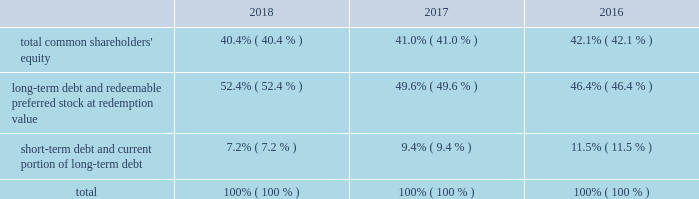Allows us to repurchase shares at times when we may otherwise be prevented from doing so under insider trading laws or because of self-imposed trading blackout periods .
Subject to applicable regulations , we may elect to amend or cancel this repurchase program or the share repurchase parameters at our discretion .
As of december 31 , 2018 , we have repurchased an aggregate of 4510000 shares of common stock under this program .
Credit facilities and short-term debt we have an unsecured revolving credit facility of $ 2.25 billion that expires in june 2023 .
In march 2018 , awcc and its lenders amended and restated the credit agreement with respect to awcc 2019s revolving credit facility to increase the maximum commitments under the facility from $ 1.75 billion to $ 2.25 billion , and to extend the expiration date of the facility from june 2020 to march 2023 .
All other terms , conditions and covenants with respect to the existing facility remained unchanged .
Subject to satisfying certain conditions , the credit agreement also permits awcc to increase the maximum commitment under the facility by up to an aggregate of $ 500 million , and to request extensions of its expiration date for up to two , one-year periods .
Interest rates on advances under the facility are based on a credit spread to the libor rate or base rate in accordance with moody investors service 2019s and standard & poor 2019s financial services 2019 then applicable credit rating on awcc 2019s senior unsecured , non-credit enhanced debt .
The facility is used principally to support awcc 2019s commercial paper program and to provide up to $ 150 million in letters of credit .
Indebtedness under the facility is considered 201cdebt 201d for purposes of a support agreement between the company and awcc , which serves as a functional equivalent of a guarantee by the company of awcc 2019s payment obligations under the credit facility .
Awcc also has an outstanding commercial paper program that is backed by the revolving credit facility , the maximum aggregate outstanding amount of which was increased in march 2018 , from $ 1.60 billion to $ 2.10 billion .
The table provides the aggregate credit facility commitments , letter of credit sub-limit under the revolving credit facility and commercial paper limit , as well as the available capacity for each as of december 31 , 2018 and 2017 : credit facility commitment available credit facility capacity letter of credit sublimit available letter of credit capacity commercial paper limit available commercial capacity ( in millions ) december 31 , 2018 .
$ 2262 $ 2177 $ 150 $ 69 $ 2100 $ 1146 december 31 , 2017 .
1762 1673 150 66 1600 695 the weighted average interest rate on awcc short-term borrowings for the years ended december 31 , 2018 and 2017 was approximately 2.28% ( 2.28 % ) and 1.24% ( 1.24 % ) , respectively .
Capital structure the table provides the percentage of our capitalization represented by the components of our capital structure as of december 31: .

By how much did the long-term debt and redeemable preferred stock at redemption value portion of the capital structure increase since 2016? 
Computations: (52.4% - 46.4%)
Answer: 0.06. 